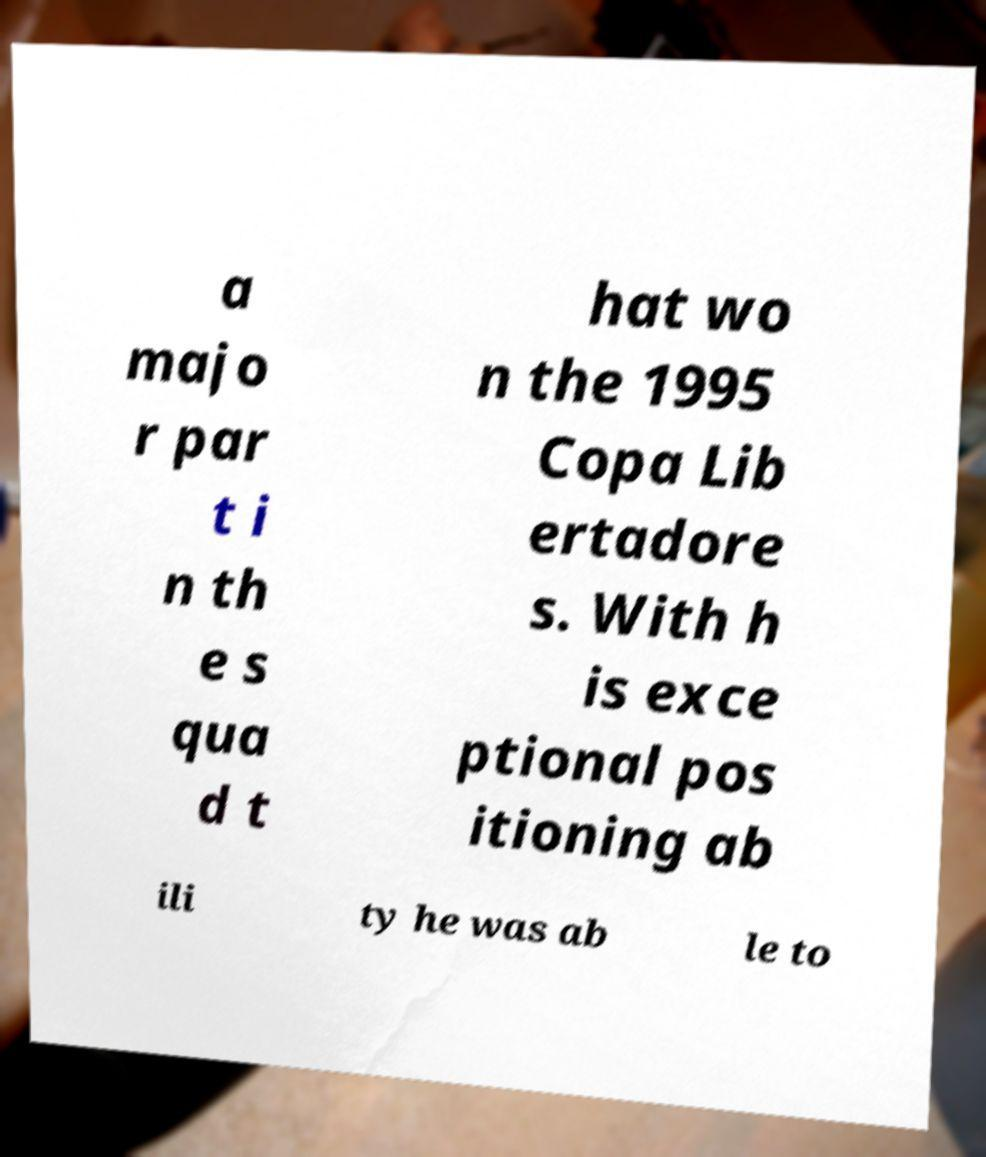What messages or text are displayed in this image? I need them in a readable, typed format. a majo r par t i n th e s qua d t hat wo n the 1995 Copa Lib ertadore s. With h is exce ptional pos itioning ab ili ty he was ab le to 